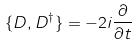Convert formula to latex. <formula><loc_0><loc_0><loc_500><loc_500>\{ D , D ^ { \dagger } \} = - 2 i \frac { \partial } { \partial t }</formula> 